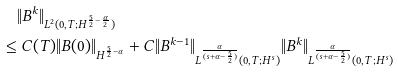<formula> <loc_0><loc_0><loc_500><loc_500>& \| B ^ { k } \| _ { L ^ { 2 } ( 0 , T ; H ^ { \frac { 5 } { 2 } - \frac { \alpha } { 2 } } ) } \\ \leq & \ C ( T ) \| B ( 0 ) \| _ { H ^ { \frac { 5 } { 2 } - \alpha } } + C \| B ^ { k - 1 } \| _ { L ^ { \frac { \alpha } { ( s + \alpha - \frac { 5 } { 2 } ) } } ( 0 , T ; H ^ { s } ) } \| B ^ { k } \| _ { L ^ { \frac { \alpha } { ( s + \alpha - \frac { 5 } { 2 } ) } } ( 0 , T ; H ^ { s } ) }</formula> 